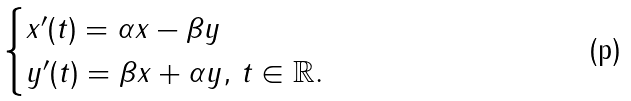<formula> <loc_0><loc_0><loc_500><loc_500>\begin{cases} x ^ { \prime } ( t ) = \alpha x - \beta y \\ y ^ { \prime } ( t ) = \beta x + \alpha y , \, t \in \mathbb { R } . \end{cases}</formula> 